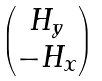Convert formula to latex. <formula><loc_0><loc_0><loc_500><loc_500>\begin{pmatrix} H _ { y } \\ - H _ { x } \end{pmatrix}</formula> 